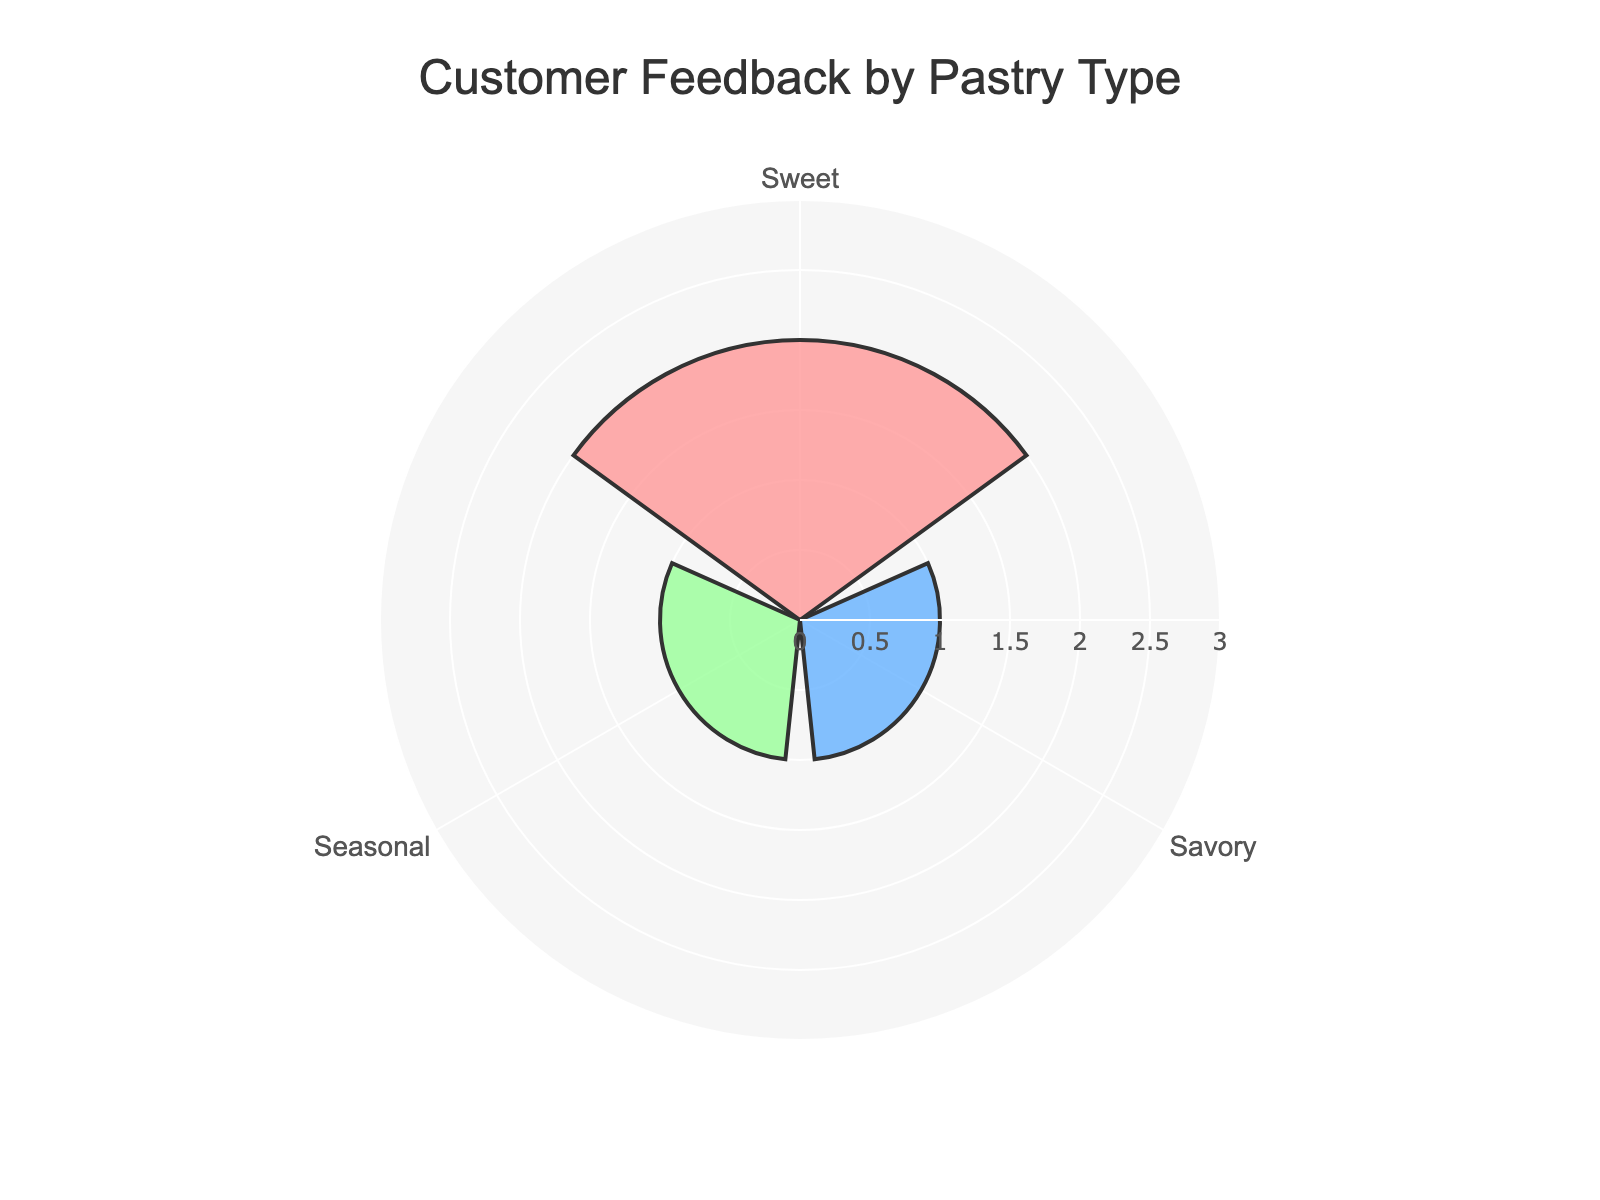What's the title of the chart? The title of the chart is written at the top of the figure in larger font size.
Answer: Customer Feedback by Pastry Type How many pastry types are rated in the chart? By looking at the labels around the polar plot, we can see three unique pastry types listed.
Answer: Three Which pastry type received the highest number of feedbacks? By comparing the radial distances (r values) of each pastry type, the one with the largest radius has the highest feedback count. The 'Sweet' category has the largest radius.
Answer: Sweet How many feedbacks did the 'Seasonal' pastry receive compared to 'Savory'? We compare the radial distances (r values) for 'Seasonal' and 'Savory'. Both have equal lengths, indicating they received an equal number of feedbacks.
Answer: Equal What is the approximate value range displayed on the radial axis? By examining radial tick marks, the smallest value starts at 0 and ends slightly above the highest value of feedback counts, which is 5, so the range is approximately from 0 to 6.
Answer: 0 to 6 How does the color coding distinguish between the different pastry types? The different colors in the plot correlate with different pastry types as per their labels. For instance:
- Sweet is colored in a light pinkish hue.
- Savory is colored in a light blue hue.
- Seasonal is colored in a light green hue.
Answer: By different colors If the 'Sweet' pastry received one more feedback, what would be the new maximum range on the radial axis? Currently, the 'Sweet' pastry has the highest number of feedbacks at 2. Adding one more feedback will take its total to 3, which is still within the current radial axis limit. However, the radial axis might need adjustment based on new relative maximums. The current max is around 6, a small increment to 3 doesn’t require a change.
Answer: No change needed How balanced is the feedback distribution among the three pastry types? Checking the lengths of the radial lines, we see the feedback counts are closely balanced as each pastry type has received the same amount of feedbacks.
Answer: Balanced If the radial axis were limited to exactly match the highest feedback count, what should the range be? Since the maximum feedback count is 2 for 'Sweet' pastries, the corresponding radial range should exactly match 2 for the polar radius. The final range should be from 0 to 2 for accurate scaling.
Answer: 0 to 2 